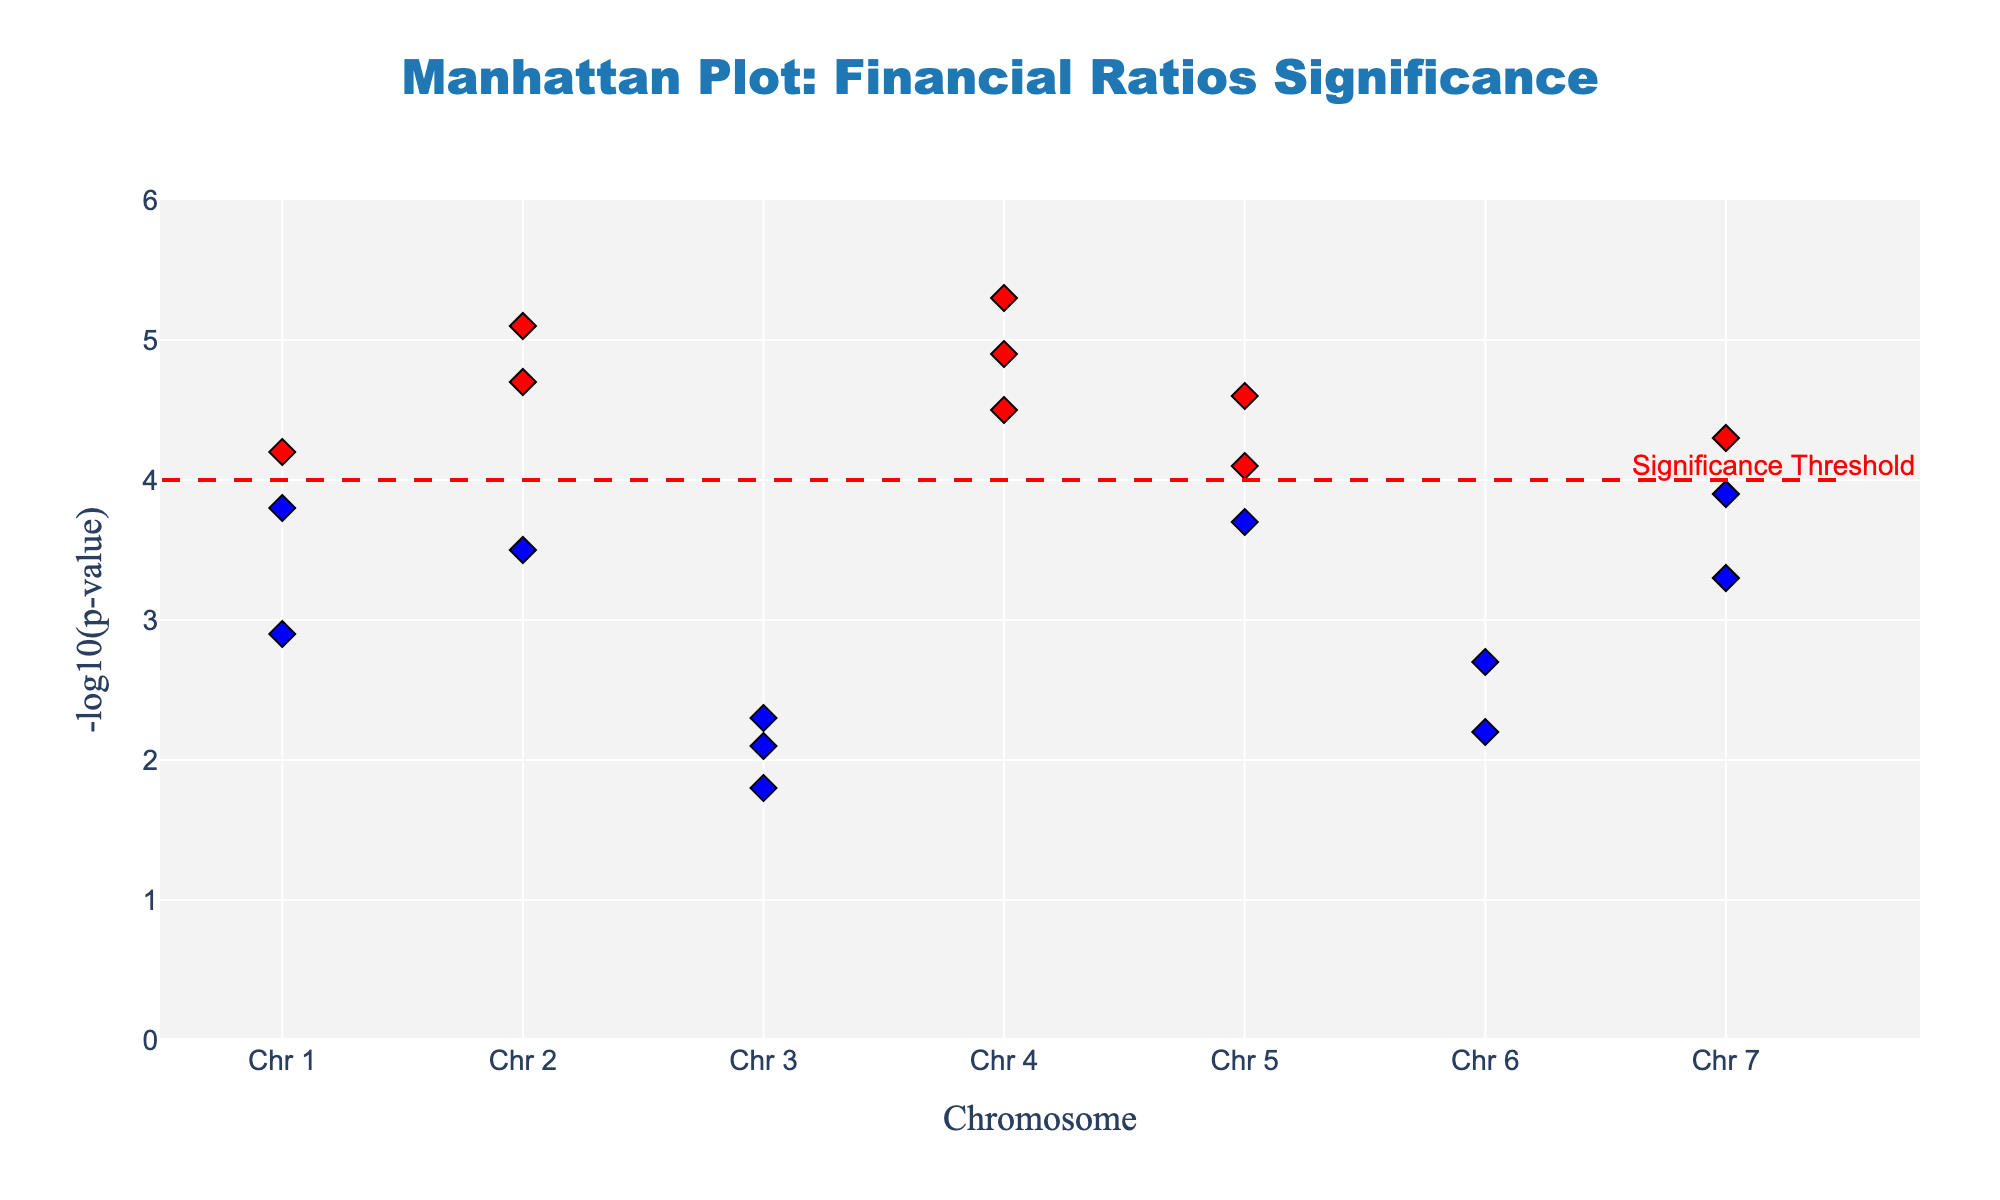What is the title of the plot? The title of the plot is usually found at the top of the chart. In this case, the title reads "Manhattan Plot: Financial Ratios Significance".
Answer: Manhattan Plot: Financial Ratios Significance What does the red dashed line represent in the plot? The red dashed line is annotated as "Significance Threshold". It represents the threshold line where -log10(p-value) = 4, indicating the level of statistical significance. Data points above this line are considered statistically significant.
Answer: Significance Threshold Which financial ratios from the plot are statistically significant? Statistically significant ratios are those with a -log10(p-value) greater than 4 and are highlighted in red in the plot. These ratios are Debt_to_Equity, Interest_Coverage, Gross_Profit_Margin, Operating_Margin, Net_Profit_Margin, Return_on_Invested_Capital, and Enterprise_Value_to_EBITDA.
Answer: Debt_to_Equity, Interest_Coverage, Gross_Profit_Margin, Operating_Margin, Net_Profit_Margin, Return_on_Invested_Capital, Enterprise_Value_to_EBITDA What is the financial ratio with the highest -log10(p-value)? The highest -log10(p-value) is indicated by the highest point on the y-axis. This point corresponds to the Net_Profit_Margin financial ratio with a -log10(p-value) of 5.3.
Answer: Net_Profit_Margin Are more financial ratios statistically significant on Chromosome 4 or Chromosome 1? Chromosome 4 has three significant points (Gross_Profit_Margin, Operating_Margin, Net_Profit_Margin) above the threshold line, while Chromosome 1 has none.
Answer: Chromosome 4 Which chromosome contains the financial ratio with the highest -log10(p-value)? Looking at the highest y-axis value for the -log10(p-value) and tracing it to the corresponding chromosome number, we find it on Chromosome 4 (Net_Profit_Margin).
Answer: Chromosome 4 Among the financial ratios related to dividends, which has the higher -log10(p-value)? The dividend-related ratios are Dividend_Payout and Dividend_Yield. Comparing their -log10(p-values) shows that Dividend_Payout has 2.7, while Dividend_Yield has 2.2. Therefore, Dividend_Payout is higher.
Answer: Dividend_Payout How many financial ratios have a -log10(p-value) between 3 and 4? The financial ratios falling in this range are Quick_Ratio, Debt_Service_Coverage, Return_on_Assets, and Return_on_Equity which sum up to four financial ratios.
Answer: 4 Which financial ratio is closest to the significance threshold without crossing it? The financial ratio closest to the threshold line (-log10(p-value) = 4) but not crossing it is Return_on_Equity with a value of 4.1.
Answer: Return_on_Equity How many chromosomes have at least one significant financial ratio? Chromosomes with significant financial ratios (identified by points above the threshold line) are Chromosome 2 (Debt_to_Equity, Interest_Coverage), Chromosome 4 (Gross_Profit_Margin, Operating_Margin, Net_Profit_Margin), and Chromosome 7 (Enterprise_Value_to_EBITDA). This results in three chromosomes.
Answer: 3 